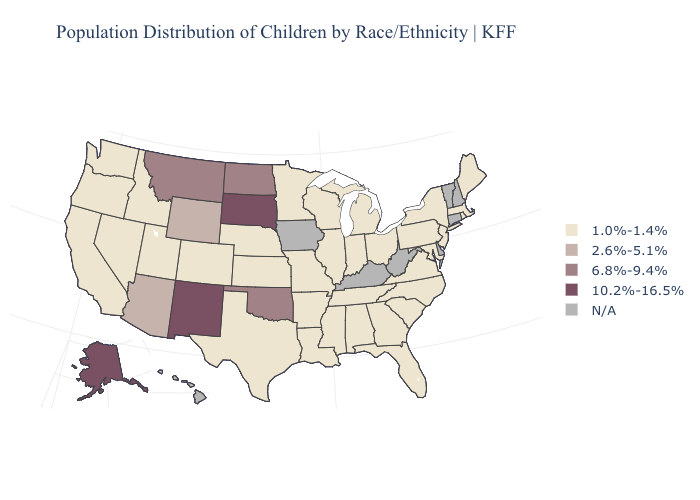What is the value of Pennsylvania?
Be succinct. 1.0%-1.4%. What is the value of Minnesota?
Keep it brief. 1.0%-1.4%. What is the highest value in states that border Georgia?
Write a very short answer. 1.0%-1.4%. Which states have the lowest value in the USA?
Concise answer only. Alabama, Arkansas, California, Colorado, Florida, Georgia, Idaho, Illinois, Indiana, Kansas, Louisiana, Maine, Maryland, Massachusetts, Michigan, Minnesota, Mississippi, Missouri, Nebraska, Nevada, New Jersey, New York, North Carolina, Ohio, Oregon, Pennsylvania, Rhode Island, South Carolina, Tennessee, Texas, Utah, Virginia, Washington, Wisconsin. Name the states that have a value in the range 1.0%-1.4%?
Quick response, please. Alabama, Arkansas, California, Colorado, Florida, Georgia, Idaho, Illinois, Indiana, Kansas, Louisiana, Maine, Maryland, Massachusetts, Michigan, Minnesota, Mississippi, Missouri, Nebraska, Nevada, New Jersey, New York, North Carolina, Ohio, Oregon, Pennsylvania, Rhode Island, South Carolina, Tennessee, Texas, Utah, Virginia, Washington, Wisconsin. What is the value of Washington?
Be succinct. 1.0%-1.4%. How many symbols are there in the legend?
Write a very short answer. 5. Does the first symbol in the legend represent the smallest category?
Answer briefly. Yes. Which states have the lowest value in the Northeast?
Quick response, please. Maine, Massachusetts, New Jersey, New York, Pennsylvania, Rhode Island. Among the states that border Rhode Island , which have the highest value?
Answer briefly. Massachusetts. What is the value of Wyoming?
Short answer required. 2.6%-5.1%. Name the states that have a value in the range 1.0%-1.4%?
Give a very brief answer. Alabama, Arkansas, California, Colorado, Florida, Georgia, Idaho, Illinois, Indiana, Kansas, Louisiana, Maine, Maryland, Massachusetts, Michigan, Minnesota, Mississippi, Missouri, Nebraska, Nevada, New Jersey, New York, North Carolina, Ohio, Oregon, Pennsylvania, Rhode Island, South Carolina, Tennessee, Texas, Utah, Virginia, Washington, Wisconsin. Does Colorado have the lowest value in the USA?
Keep it brief. Yes. 